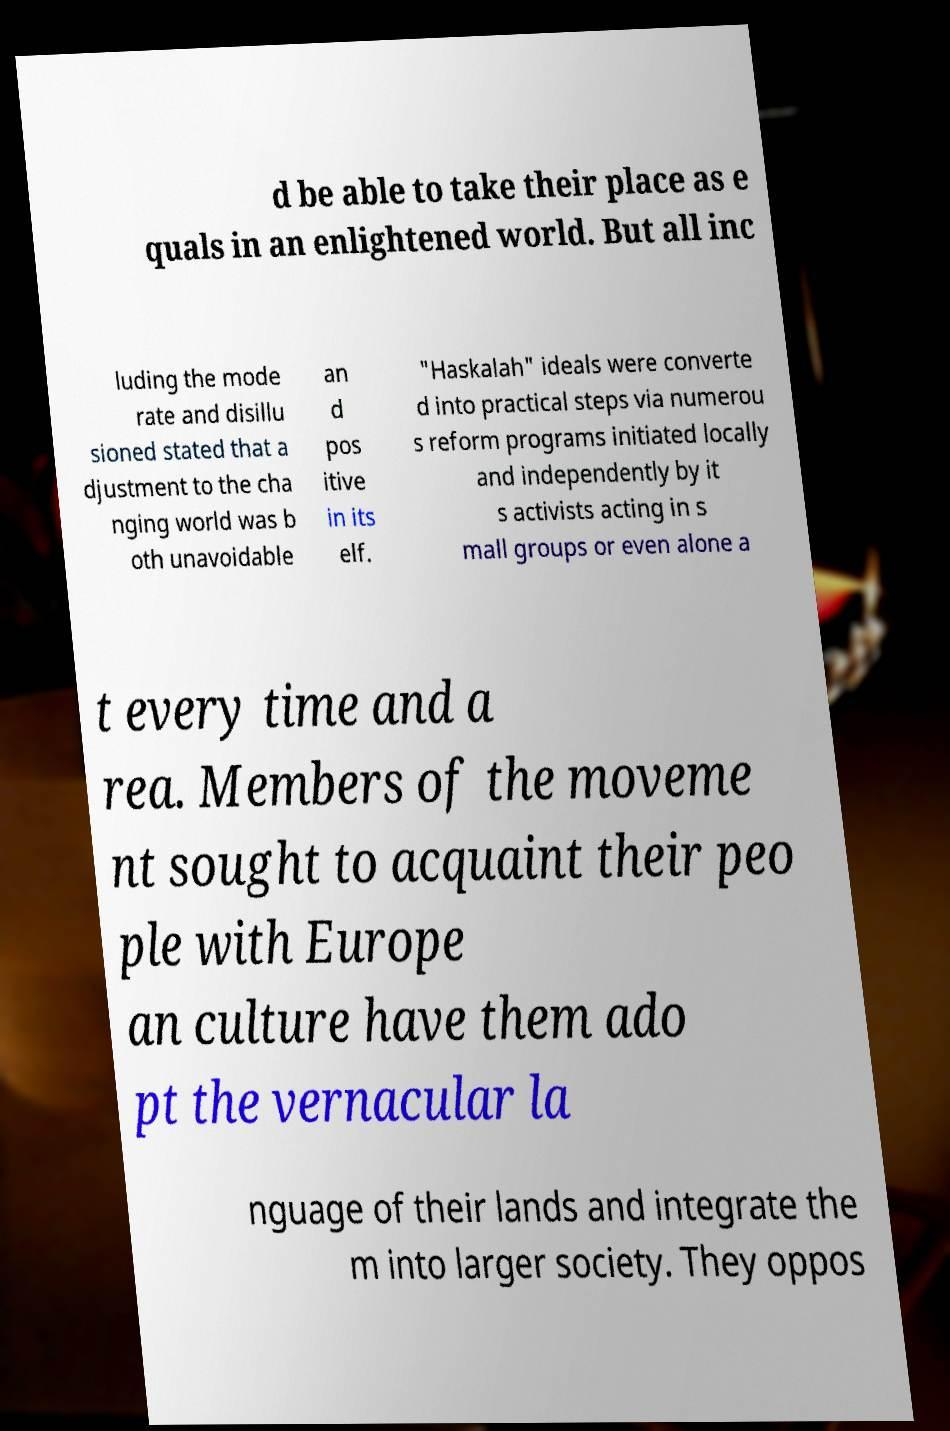Could you extract and type out the text from this image? d be able to take their place as e quals in an enlightened world. But all inc luding the mode rate and disillu sioned stated that a djustment to the cha nging world was b oth unavoidable an d pos itive in its elf. "Haskalah" ideals were converte d into practical steps via numerou s reform programs initiated locally and independently by it s activists acting in s mall groups or even alone a t every time and a rea. Members of the moveme nt sought to acquaint their peo ple with Europe an culture have them ado pt the vernacular la nguage of their lands and integrate the m into larger society. They oppos 